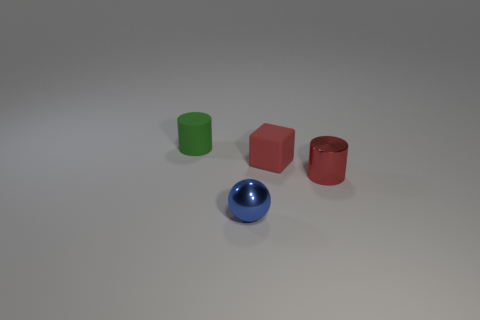What number of things are cylinders or blocks? 3 